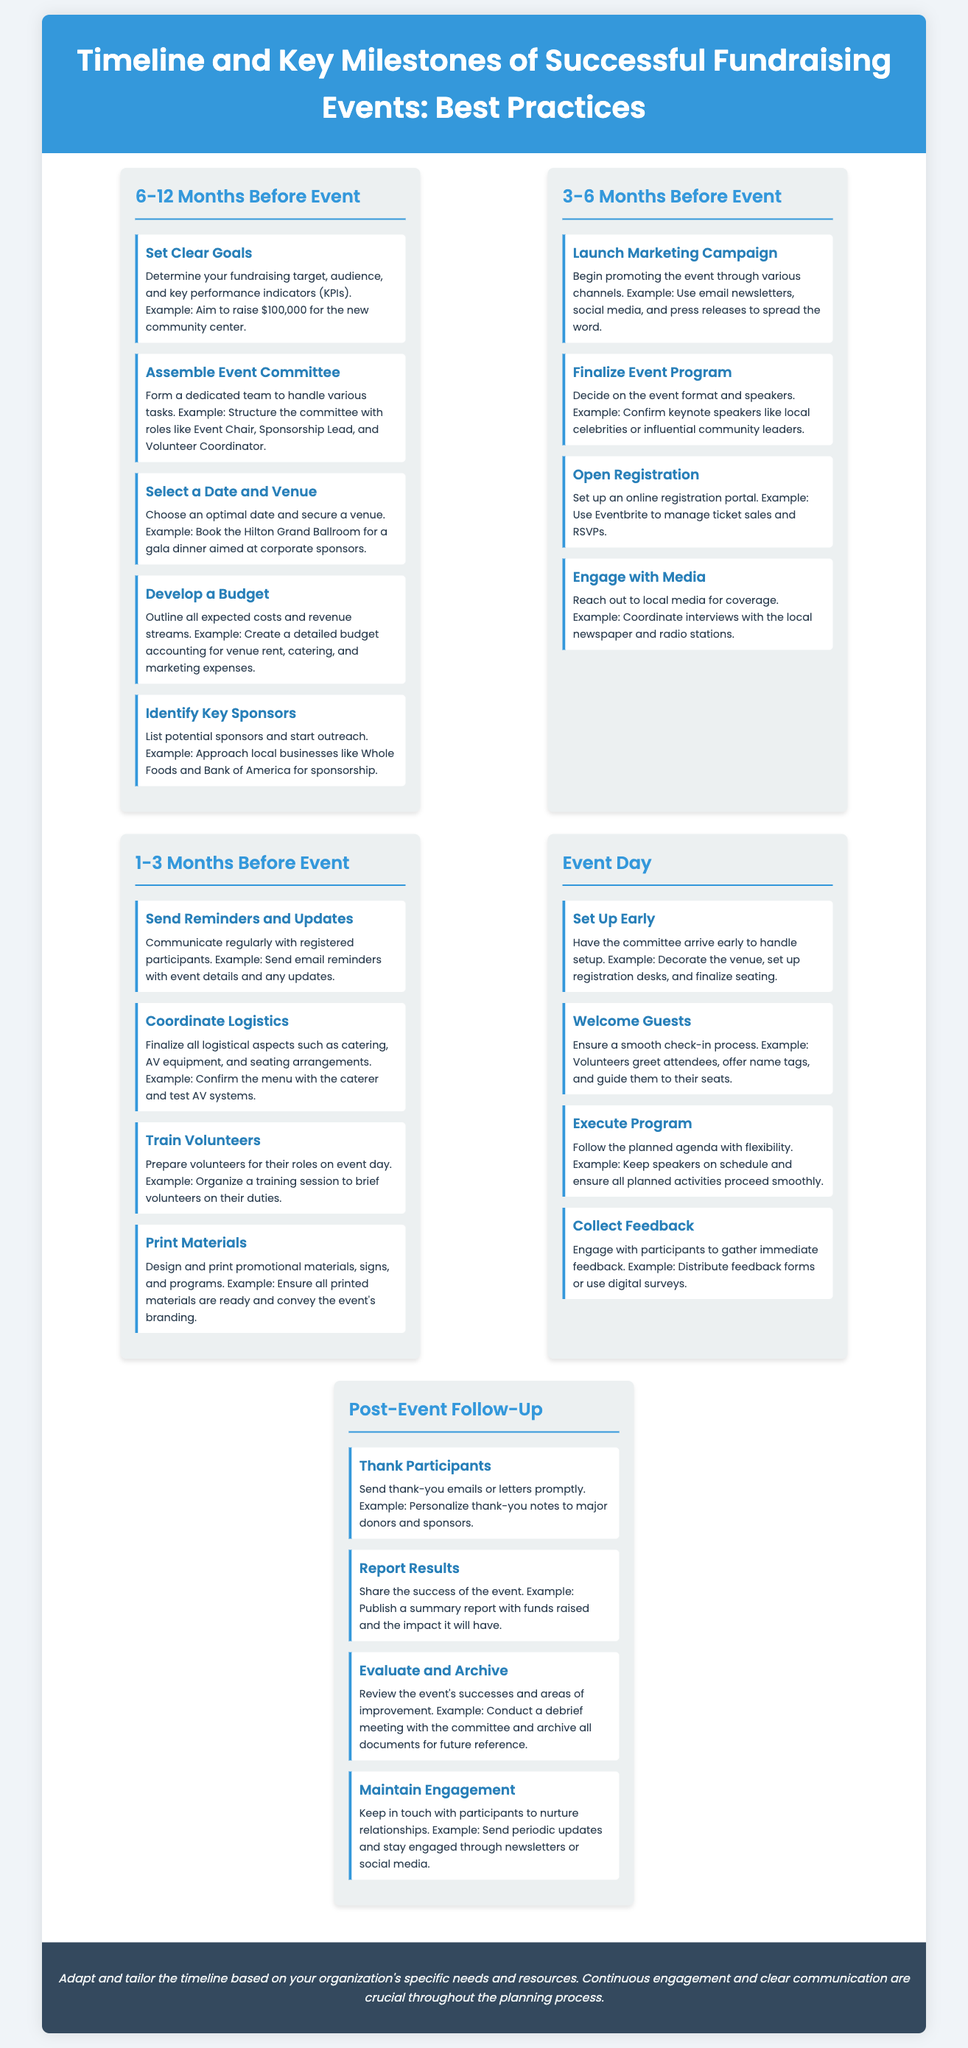what should be done 6-12 months before the event? The section outlines key tasks to accomplish in this timeframe, including setting clear goals, assembling an event committee, selecting a date and venue, developing a budget, and identifying key sponsors.
Answer: Set Clear Goals, Assemble Event Committee, Select a Date and Venue, Develop a Budget, Identify Key Sponsors how many months prior should the marketing campaign be launched? The document specifies that the marketing campaign should be launched 3-6 months before the event.
Answer: 3-6 months what is an example given for engaging with media? The document provides an example of reaching out to local media for coverage and coordinating interviews.
Answer: Coordinate interviews with the local newspaper and radio stations what action is advised on event day regarding guest check-in? The document emphasizes ensuring a smooth check-in process for guests, which is vital for a successful event day.
Answer: Ensure a smooth check-in process what is one of the post-event follow-up activities? The document indicates that sending thank-you emails or letters promptly to participants is essential.
Answer: Thank Participants what is advised for volunteer training? The document suggests preparing volunteers for their roles and organizing a training session to brief them on their duties.
Answer: Organize a training session to brief volunteers on their duties what is a crucial document type-specific element mentioned during the event? The document highlights the importance of executing the program while maintaining flexibility during the event.
Answer: Execute Program how should results be reported after the event? The document advises sharing the success of the event by publishing a summary report with funds raised and the impact it will have.
Answer: Publish a summary report with funds raised and the impact it will have 